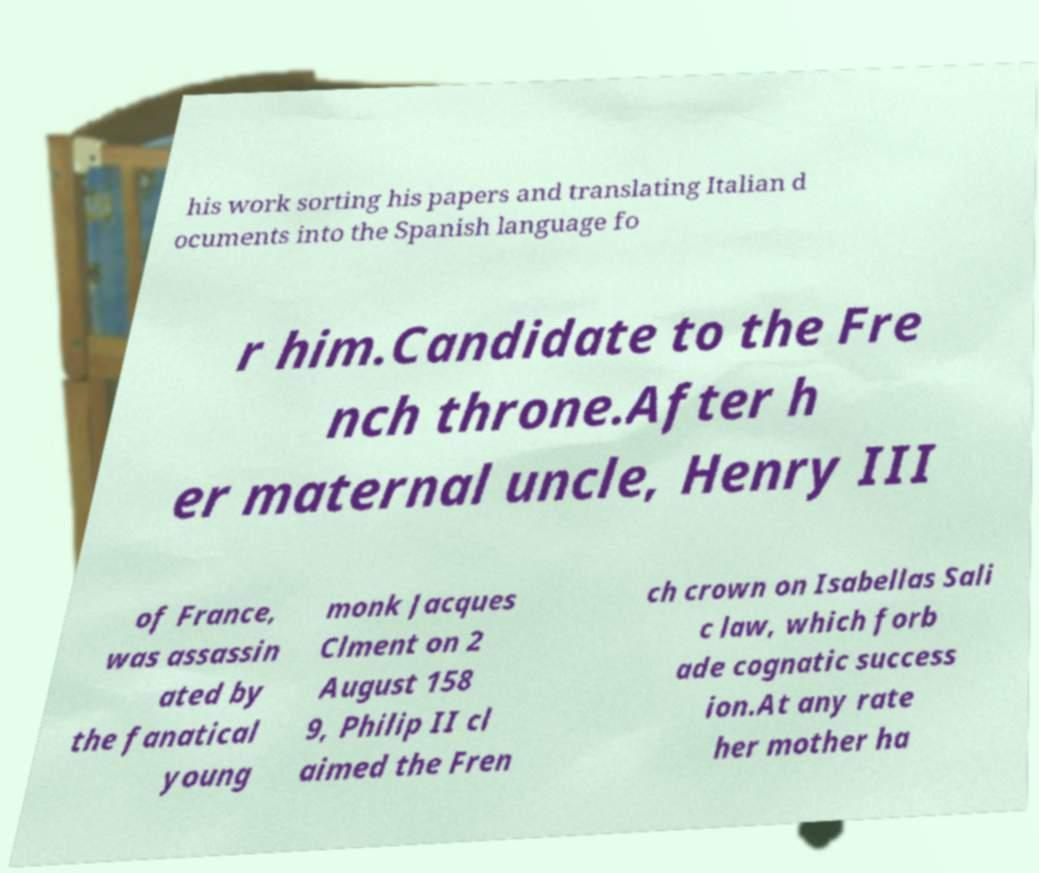There's text embedded in this image that I need extracted. Can you transcribe it verbatim? his work sorting his papers and translating Italian d ocuments into the Spanish language fo r him.Candidate to the Fre nch throne.After h er maternal uncle, Henry III of France, was assassin ated by the fanatical young monk Jacques Clment on 2 August 158 9, Philip II cl aimed the Fren ch crown on Isabellas Sali c law, which forb ade cognatic success ion.At any rate her mother ha 